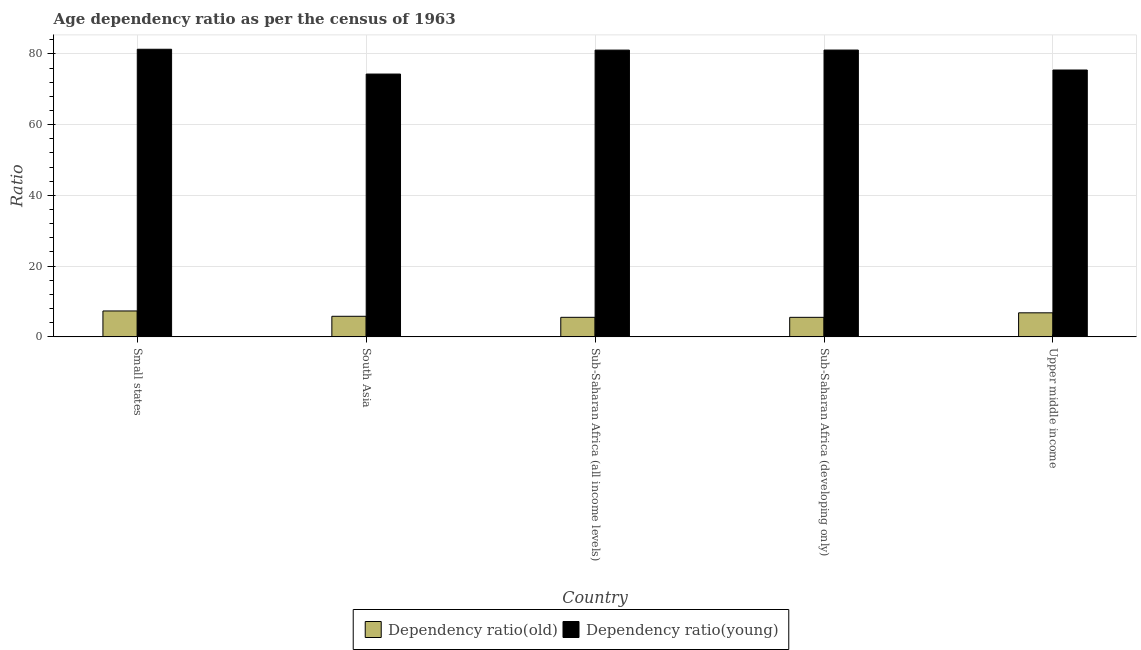How many different coloured bars are there?
Provide a short and direct response. 2. Are the number of bars per tick equal to the number of legend labels?
Provide a short and direct response. Yes. How many bars are there on the 3rd tick from the left?
Provide a short and direct response. 2. What is the label of the 5th group of bars from the left?
Keep it short and to the point. Upper middle income. In how many cases, is the number of bars for a given country not equal to the number of legend labels?
Provide a short and direct response. 0. What is the age dependency ratio(old) in Sub-Saharan Africa (all income levels)?
Offer a terse response. 5.53. Across all countries, what is the maximum age dependency ratio(old)?
Ensure brevity in your answer.  7.32. Across all countries, what is the minimum age dependency ratio(young)?
Offer a very short reply. 74.31. In which country was the age dependency ratio(young) maximum?
Offer a very short reply. Small states. In which country was the age dependency ratio(young) minimum?
Offer a terse response. South Asia. What is the total age dependency ratio(old) in the graph?
Give a very brief answer. 30.99. What is the difference between the age dependency ratio(old) in Sub-Saharan Africa (developing only) and that in Upper middle income?
Offer a very short reply. -1.28. What is the difference between the age dependency ratio(old) in Upper middle income and the age dependency ratio(young) in South Asia?
Your response must be concise. -67.51. What is the average age dependency ratio(old) per country?
Offer a very short reply. 6.2. What is the difference between the age dependency ratio(young) and age dependency ratio(old) in Sub-Saharan Africa (developing only)?
Keep it short and to the point. 75.57. What is the ratio of the age dependency ratio(old) in Small states to that in Sub-Saharan Africa (developing only)?
Provide a short and direct response. 1.33. Is the difference between the age dependency ratio(young) in South Asia and Upper middle income greater than the difference between the age dependency ratio(old) in South Asia and Upper middle income?
Your answer should be very brief. No. What is the difference between the highest and the second highest age dependency ratio(young)?
Make the answer very short. 0.22. What is the difference between the highest and the lowest age dependency ratio(young)?
Offer a terse response. 7.01. Is the sum of the age dependency ratio(old) in Small states and Sub-Saharan Africa (all income levels) greater than the maximum age dependency ratio(young) across all countries?
Offer a terse response. No. What does the 1st bar from the left in Sub-Saharan Africa (all income levels) represents?
Keep it short and to the point. Dependency ratio(old). What does the 1st bar from the right in Sub-Saharan Africa (all income levels) represents?
Keep it short and to the point. Dependency ratio(young). How many bars are there?
Offer a very short reply. 10. Are all the bars in the graph horizontal?
Your answer should be compact. No. Does the graph contain any zero values?
Keep it short and to the point. No. Does the graph contain grids?
Provide a succinct answer. Yes. What is the title of the graph?
Your answer should be compact. Age dependency ratio as per the census of 1963. Does "Female" appear as one of the legend labels in the graph?
Your answer should be compact. No. What is the label or title of the X-axis?
Provide a succinct answer. Country. What is the label or title of the Y-axis?
Ensure brevity in your answer.  Ratio. What is the Ratio in Dependency ratio(old) in Small states?
Give a very brief answer. 7.32. What is the Ratio in Dependency ratio(young) in Small states?
Offer a very short reply. 81.32. What is the Ratio in Dependency ratio(old) in South Asia?
Provide a succinct answer. 5.82. What is the Ratio in Dependency ratio(young) in South Asia?
Ensure brevity in your answer.  74.31. What is the Ratio in Dependency ratio(old) in Sub-Saharan Africa (all income levels)?
Your response must be concise. 5.53. What is the Ratio in Dependency ratio(young) in Sub-Saharan Africa (all income levels)?
Provide a short and direct response. 81.07. What is the Ratio in Dependency ratio(old) in Sub-Saharan Africa (developing only)?
Your answer should be compact. 5.52. What is the Ratio in Dependency ratio(young) in Sub-Saharan Africa (developing only)?
Offer a very short reply. 81.09. What is the Ratio in Dependency ratio(old) in Upper middle income?
Ensure brevity in your answer.  6.8. What is the Ratio in Dependency ratio(young) in Upper middle income?
Give a very brief answer. 75.45. Across all countries, what is the maximum Ratio in Dependency ratio(old)?
Offer a terse response. 7.32. Across all countries, what is the maximum Ratio of Dependency ratio(young)?
Ensure brevity in your answer.  81.32. Across all countries, what is the minimum Ratio in Dependency ratio(old)?
Provide a short and direct response. 5.52. Across all countries, what is the minimum Ratio in Dependency ratio(young)?
Ensure brevity in your answer.  74.31. What is the total Ratio in Dependency ratio(old) in the graph?
Offer a very short reply. 30.99. What is the total Ratio of Dependency ratio(young) in the graph?
Your response must be concise. 393.24. What is the difference between the Ratio of Dependency ratio(old) in Small states and that in South Asia?
Your answer should be compact. 1.5. What is the difference between the Ratio in Dependency ratio(young) in Small states and that in South Asia?
Your answer should be compact. 7.01. What is the difference between the Ratio of Dependency ratio(old) in Small states and that in Sub-Saharan Africa (all income levels)?
Your answer should be compact. 1.8. What is the difference between the Ratio of Dependency ratio(young) in Small states and that in Sub-Saharan Africa (all income levels)?
Give a very brief answer. 0.24. What is the difference between the Ratio of Dependency ratio(old) in Small states and that in Sub-Saharan Africa (developing only)?
Give a very brief answer. 1.8. What is the difference between the Ratio in Dependency ratio(young) in Small states and that in Sub-Saharan Africa (developing only)?
Give a very brief answer. 0.22. What is the difference between the Ratio of Dependency ratio(old) in Small states and that in Upper middle income?
Offer a terse response. 0.52. What is the difference between the Ratio of Dependency ratio(young) in Small states and that in Upper middle income?
Your answer should be very brief. 5.87. What is the difference between the Ratio in Dependency ratio(old) in South Asia and that in Sub-Saharan Africa (all income levels)?
Offer a very short reply. 0.29. What is the difference between the Ratio in Dependency ratio(young) in South Asia and that in Sub-Saharan Africa (all income levels)?
Offer a very short reply. -6.77. What is the difference between the Ratio of Dependency ratio(old) in South Asia and that in Sub-Saharan Africa (developing only)?
Provide a succinct answer. 0.3. What is the difference between the Ratio in Dependency ratio(young) in South Asia and that in Sub-Saharan Africa (developing only)?
Your response must be concise. -6.79. What is the difference between the Ratio in Dependency ratio(old) in South Asia and that in Upper middle income?
Give a very brief answer. -0.98. What is the difference between the Ratio in Dependency ratio(young) in South Asia and that in Upper middle income?
Make the answer very short. -1.14. What is the difference between the Ratio of Dependency ratio(old) in Sub-Saharan Africa (all income levels) and that in Sub-Saharan Africa (developing only)?
Provide a succinct answer. 0. What is the difference between the Ratio in Dependency ratio(young) in Sub-Saharan Africa (all income levels) and that in Sub-Saharan Africa (developing only)?
Provide a short and direct response. -0.02. What is the difference between the Ratio in Dependency ratio(old) in Sub-Saharan Africa (all income levels) and that in Upper middle income?
Provide a short and direct response. -1.27. What is the difference between the Ratio in Dependency ratio(young) in Sub-Saharan Africa (all income levels) and that in Upper middle income?
Your response must be concise. 5.63. What is the difference between the Ratio of Dependency ratio(old) in Sub-Saharan Africa (developing only) and that in Upper middle income?
Provide a succinct answer. -1.28. What is the difference between the Ratio in Dependency ratio(young) in Sub-Saharan Africa (developing only) and that in Upper middle income?
Make the answer very short. 5.64. What is the difference between the Ratio of Dependency ratio(old) in Small states and the Ratio of Dependency ratio(young) in South Asia?
Your response must be concise. -66.98. What is the difference between the Ratio of Dependency ratio(old) in Small states and the Ratio of Dependency ratio(young) in Sub-Saharan Africa (all income levels)?
Your answer should be compact. -73.75. What is the difference between the Ratio in Dependency ratio(old) in Small states and the Ratio in Dependency ratio(young) in Sub-Saharan Africa (developing only)?
Offer a very short reply. -73.77. What is the difference between the Ratio of Dependency ratio(old) in Small states and the Ratio of Dependency ratio(young) in Upper middle income?
Offer a terse response. -68.12. What is the difference between the Ratio of Dependency ratio(old) in South Asia and the Ratio of Dependency ratio(young) in Sub-Saharan Africa (all income levels)?
Your response must be concise. -75.26. What is the difference between the Ratio of Dependency ratio(old) in South Asia and the Ratio of Dependency ratio(young) in Sub-Saharan Africa (developing only)?
Your answer should be very brief. -75.27. What is the difference between the Ratio in Dependency ratio(old) in South Asia and the Ratio in Dependency ratio(young) in Upper middle income?
Make the answer very short. -69.63. What is the difference between the Ratio in Dependency ratio(old) in Sub-Saharan Africa (all income levels) and the Ratio in Dependency ratio(young) in Sub-Saharan Africa (developing only)?
Your response must be concise. -75.56. What is the difference between the Ratio in Dependency ratio(old) in Sub-Saharan Africa (all income levels) and the Ratio in Dependency ratio(young) in Upper middle income?
Make the answer very short. -69.92. What is the difference between the Ratio in Dependency ratio(old) in Sub-Saharan Africa (developing only) and the Ratio in Dependency ratio(young) in Upper middle income?
Ensure brevity in your answer.  -69.93. What is the average Ratio in Dependency ratio(old) per country?
Keep it short and to the point. 6.2. What is the average Ratio in Dependency ratio(young) per country?
Your response must be concise. 78.65. What is the difference between the Ratio of Dependency ratio(old) and Ratio of Dependency ratio(young) in Small states?
Offer a very short reply. -73.99. What is the difference between the Ratio of Dependency ratio(old) and Ratio of Dependency ratio(young) in South Asia?
Your answer should be very brief. -68.49. What is the difference between the Ratio of Dependency ratio(old) and Ratio of Dependency ratio(young) in Sub-Saharan Africa (all income levels)?
Provide a succinct answer. -75.55. What is the difference between the Ratio of Dependency ratio(old) and Ratio of Dependency ratio(young) in Sub-Saharan Africa (developing only)?
Ensure brevity in your answer.  -75.57. What is the difference between the Ratio of Dependency ratio(old) and Ratio of Dependency ratio(young) in Upper middle income?
Your answer should be compact. -68.65. What is the ratio of the Ratio in Dependency ratio(old) in Small states to that in South Asia?
Keep it short and to the point. 1.26. What is the ratio of the Ratio in Dependency ratio(young) in Small states to that in South Asia?
Provide a succinct answer. 1.09. What is the ratio of the Ratio of Dependency ratio(old) in Small states to that in Sub-Saharan Africa (all income levels)?
Offer a terse response. 1.32. What is the ratio of the Ratio of Dependency ratio(old) in Small states to that in Sub-Saharan Africa (developing only)?
Offer a terse response. 1.33. What is the ratio of the Ratio of Dependency ratio(young) in Small states to that in Sub-Saharan Africa (developing only)?
Offer a very short reply. 1. What is the ratio of the Ratio in Dependency ratio(old) in Small states to that in Upper middle income?
Provide a succinct answer. 1.08. What is the ratio of the Ratio in Dependency ratio(young) in Small states to that in Upper middle income?
Provide a succinct answer. 1.08. What is the ratio of the Ratio in Dependency ratio(old) in South Asia to that in Sub-Saharan Africa (all income levels)?
Offer a terse response. 1.05. What is the ratio of the Ratio of Dependency ratio(young) in South Asia to that in Sub-Saharan Africa (all income levels)?
Ensure brevity in your answer.  0.92. What is the ratio of the Ratio in Dependency ratio(old) in South Asia to that in Sub-Saharan Africa (developing only)?
Offer a very short reply. 1.05. What is the ratio of the Ratio of Dependency ratio(young) in South Asia to that in Sub-Saharan Africa (developing only)?
Make the answer very short. 0.92. What is the ratio of the Ratio of Dependency ratio(old) in South Asia to that in Upper middle income?
Offer a terse response. 0.86. What is the ratio of the Ratio of Dependency ratio(old) in Sub-Saharan Africa (all income levels) to that in Upper middle income?
Your answer should be very brief. 0.81. What is the ratio of the Ratio of Dependency ratio(young) in Sub-Saharan Africa (all income levels) to that in Upper middle income?
Offer a very short reply. 1.07. What is the ratio of the Ratio of Dependency ratio(old) in Sub-Saharan Africa (developing only) to that in Upper middle income?
Make the answer very short. 0.81. What is the ratio of the Ratio in Dependency ratio(young) in Sub-Saharan Africa (developing only) to that in Upper middle income?
Make the answer very short. 1.07. What is the difference between the highest and the second highest Ratio of Dependency ratio(old)?
Offer a very short reply. 0.52. What is the difference between the highest and the second highest Ratio in Dependency ratio(young)?
Provide a short and direct response. 0.22. What is the difference between the highest and the lowest Ratio of Dependency ratio(old)?
Your answer should be very brief. 1.8. What is the difference between the highest and the lowest Ratio of Dependency ratio(young)?
Make the answer very short. 7.01. 